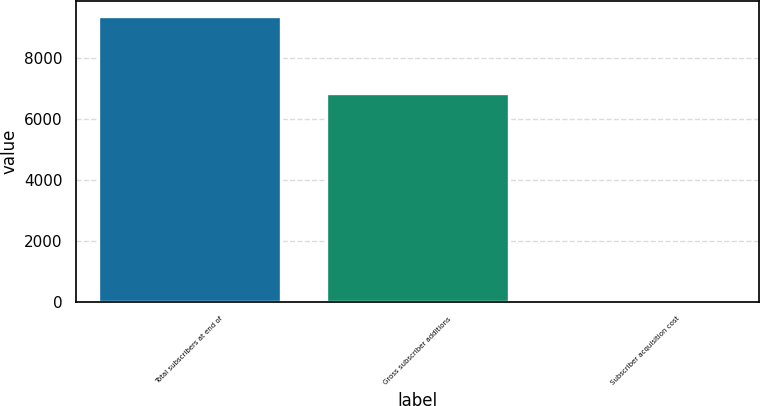Convert chart. <chart><loc_0><loc_0><loc_500><loc_500><bar_chart><fcel>Total subscribers at end of<fcel>Gross subscriber additions<fcel>Subscriber acquisition cost<nl><fcel>9390<fcel>6859<fcel>29.12<nl></chart> 